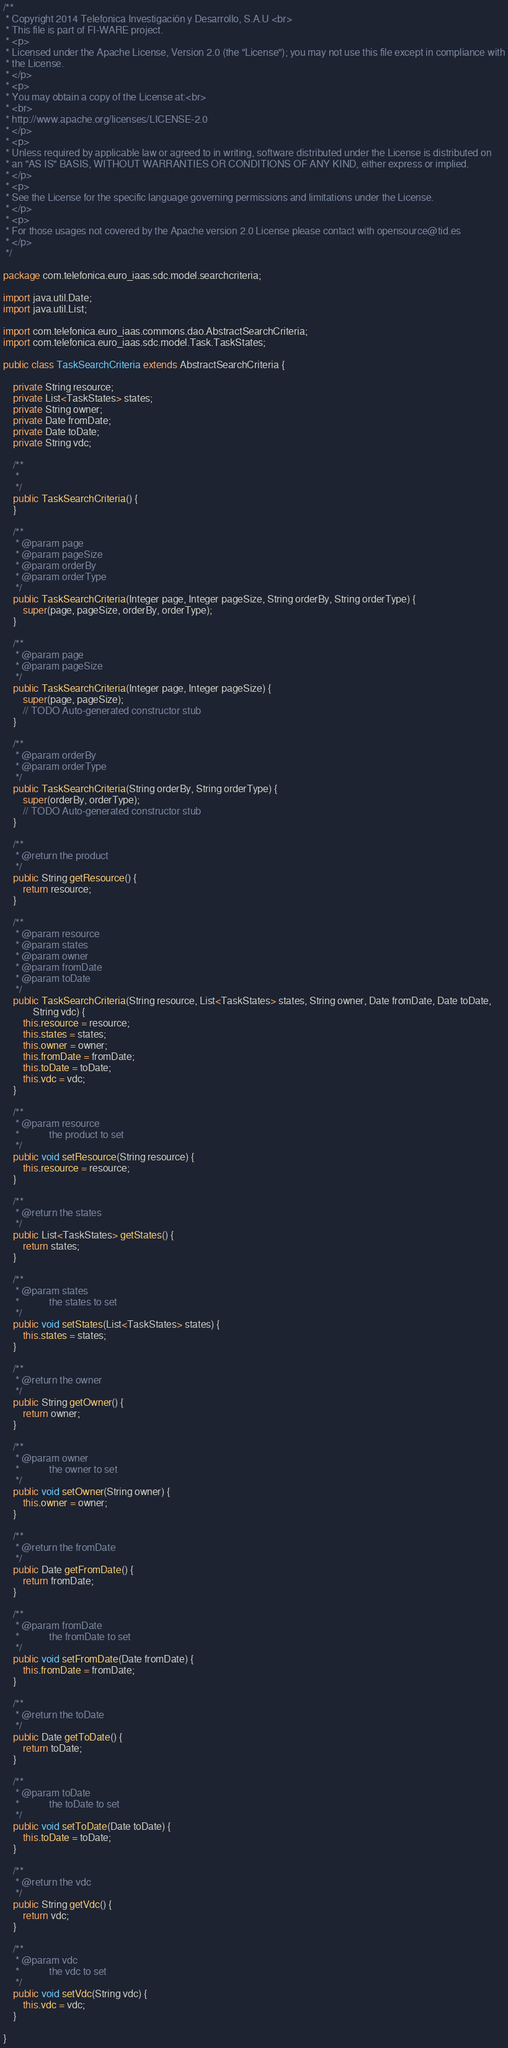<code> <loc_0><loc_0><loc_500><loc_500><_Java_>/**
 * Copyright 2014 Telefonica Investigación y Desarrollo, S.A.U <br>
 * This file is part of FI-WARE project.
 * <p>
 * Licensed under the Apache License, Version 2.0 (the "License"); you may not use this file except in compliance with
 * the License.
 * </p>
 * <p>
 * You may obtain a copy of the License at:<br>
 * <br>
 * http://www.apache.org/licenses/LICENSE-2.0
 * </p>
 * <p>
 * Unless required by applicable law or agreed to in writing, software distributed under the License is distributed on
 * an "AS IS" BASIS, WITHOUT WARRANTIES OR CONDITIONS OF ANY KIND, either express or implied.
 * </p>
 * <p>
 * See the License for the specific language governing permissions and limitations under the License.
 * </p>
 * <p>
 * For those usages not covered by the Apache version 2.0 License please contact with opensource@tid.es
 * </p>
 */

package com.telefonica.euro_iaas.sdc.model.searchcriteria;

import java.util.Date;
import java.util.List;

import com.telefonica.euro_iaas.commons.dao.AbstractSearchCriteria;
import com.telefonica.euro_iaas.sdc.model.Task.TaskStates;

public class TaskSearchCriteria extends AbstractSearchCriteria {

    private String resource;
    private List<TaskStates> states;
    private String owner;
    private Date fromDate;
    private Date toDate;
    private String vdc;

    /**
     *
     */
    public TaskSearchCriteria() {
    }

    /**
     * @param page
     * @param pageSize
     * @param orderBy
     * @param orderType
     */
    public TaskSearchCriteria(Integer page, Integer pageSize, String orderBy, String orderType) {
        super(page, pageSize, orderBy, orderType);
    }

    /**
     * @param page
     * @param pageSize
     */
    public TaskSearchCriteria(Integer page, Integer pageSize) {
        super(page, pageSize);
        // TODO Auto-generated constructor stub
    }

    /**
     * @param orderBy
     * @param orderType
     */
    public TaskSearchCriteria(String orderBy, String orderType) {
        super(orderBy, orderType);
        // TODO Auto-generated constructor stub
    }

    /**
     * @return the product
     */
    public String getResource() {
        return resource;
    }

    /**
     * @param resource
     * @param states
     * @param owner
     * @param fromDate
     * @param toDate
     */
    public TaskSearchCriteria(String resource, List<TaskStates> states, String owner, Date fromDate, Date toDate,
            String vdc) {
        this.resource = resource;
        this.states = states;
        this.owner = owner;
        this.fromDate = fromDate;
        this.toDate = toDate;
        this.vdc = vdc;
    }

    /**
     * @param resource
     *            the product to set
     */
    public void setResource(String resource) {
        this.resource = resource;
    }

    /**
     * @return the states
     */
    public List<TaskStates> getStates() {
        return states;
    }

    /**
     * @param states
     *            the states to set
     */
    public void setStates(List<TaskStates> states) {
        this.states = states;
    }

    /**
     * @return the owner
     */
    public String getOwner() {
        return owner;
    }

    /**
     * @param owner
     *            the owner to set
     */
    public void setOwner(String owner) {
        this.owner = owner;
    }

    /**
     * @return the fromDate
     */
    public Date getFromDate() {
        return fromDate;
    }

    /**
     * @param fromDate
     *            the fromDate to set
     */
    public void setFromDate(Date fromDate) {
        this.fromDate = fromDate;
    }

    /**
     * @return the toDate
     */
    public Date getToDate() {
        return toDate;
    }

    /**
     * @param toDate
     *            the toDate to set
     */
    public void setToDate(Date toDate) {
        this.toDate = toDate;
    }

    /**
     * @return the vdc
     */
    public String getVdc() {
        return vdc;
    }

    /**
     * @param vdc
     *            the vdc to set
     */
    public void setVdc(String vdc) {
        this.vdc = vdc;
    }

}
</code> 